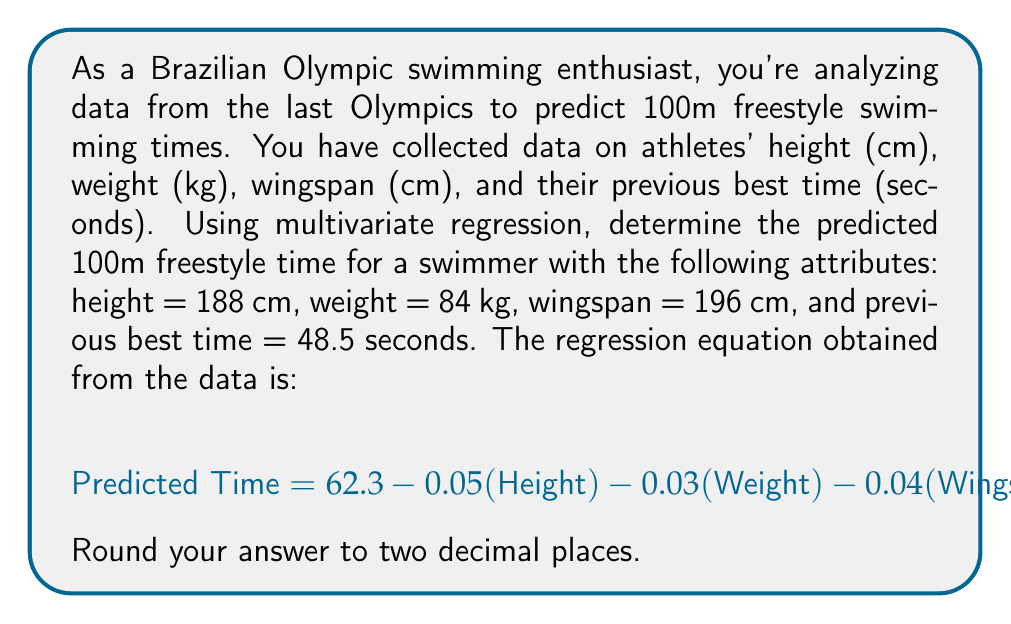Can you answer this question? To solve this problem, we need to use the given multivariate regression equation and substitute the values for each variable. Let's break it down step by step:

1. Given regression equation:
   $$\text{Predicted Time} = 62.3 - 0.05(\text{Height}) - 0.03(\text{Weight}) - 0.04(\text{Wingspan}) + 0.7(\text{Previous Best Time})$$

2. Substitute the given values:
   - Height = 188 cm
   - Weight = 84 kg
   - Wingspan = 196 cm
   - Previous Best Time = 48.5 seconds

3. Calculate each term:
   - $62.3$ (constant term)
   - $-0.05 \times 188 = -9.4$
   - $-0.03 \times 84 = -2.52$
   - $-0.04 \times 196 = -7.84$
   - $0.7 \times 48.5 = 33.95$

4. Sum up all the terms:
   $$\text{Predicted Time} = 62.3 + (-9.4) + (-2.52) + (-7.84) + 33.95$$

5. Perform the calculation:
   $$\text{Predicted Time} = 76.49$$

6. Round to two decimal places:
   $$\text{Predicted Time} = 76.49 \approx 76.49 \text{ seconds}$$
Answer: 76.49 seconds 